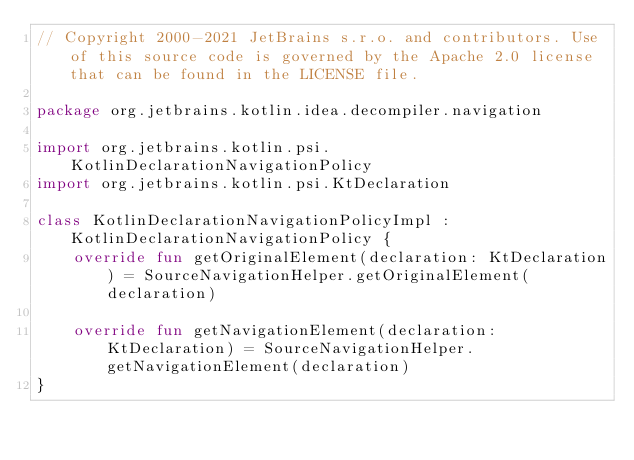<code> <loc_0><loc_0><loc_500><loc_500><_Kotlin_>// Copyright 2000-2021 JetBrains s.r.o. and contributors. Use of this source code is governed by the Apache 2.0 license that can be found in the LICENSE file.

package org.jetbrains.kotlin.idea.decompiler.navigation

import org.jetbrains.kotlin.psi.KotlinDeclarationNavigationPolicy
import org.jetbrains.kotlin.psi.KtDeclaration

class KotlinDeclarationNavigationPolicyImpl : KotlinDeclarationNavigationPolicy {
    override fun getOriginalElement(declaration: KtDeclaration) = SourceNavigationHelper.getOriginalElement(declaration)

    override fun getNavigationElement(declaration: KtDeclaration) = SourceNavigationHelper.getNavigationElement(declaration)
}
</code> 